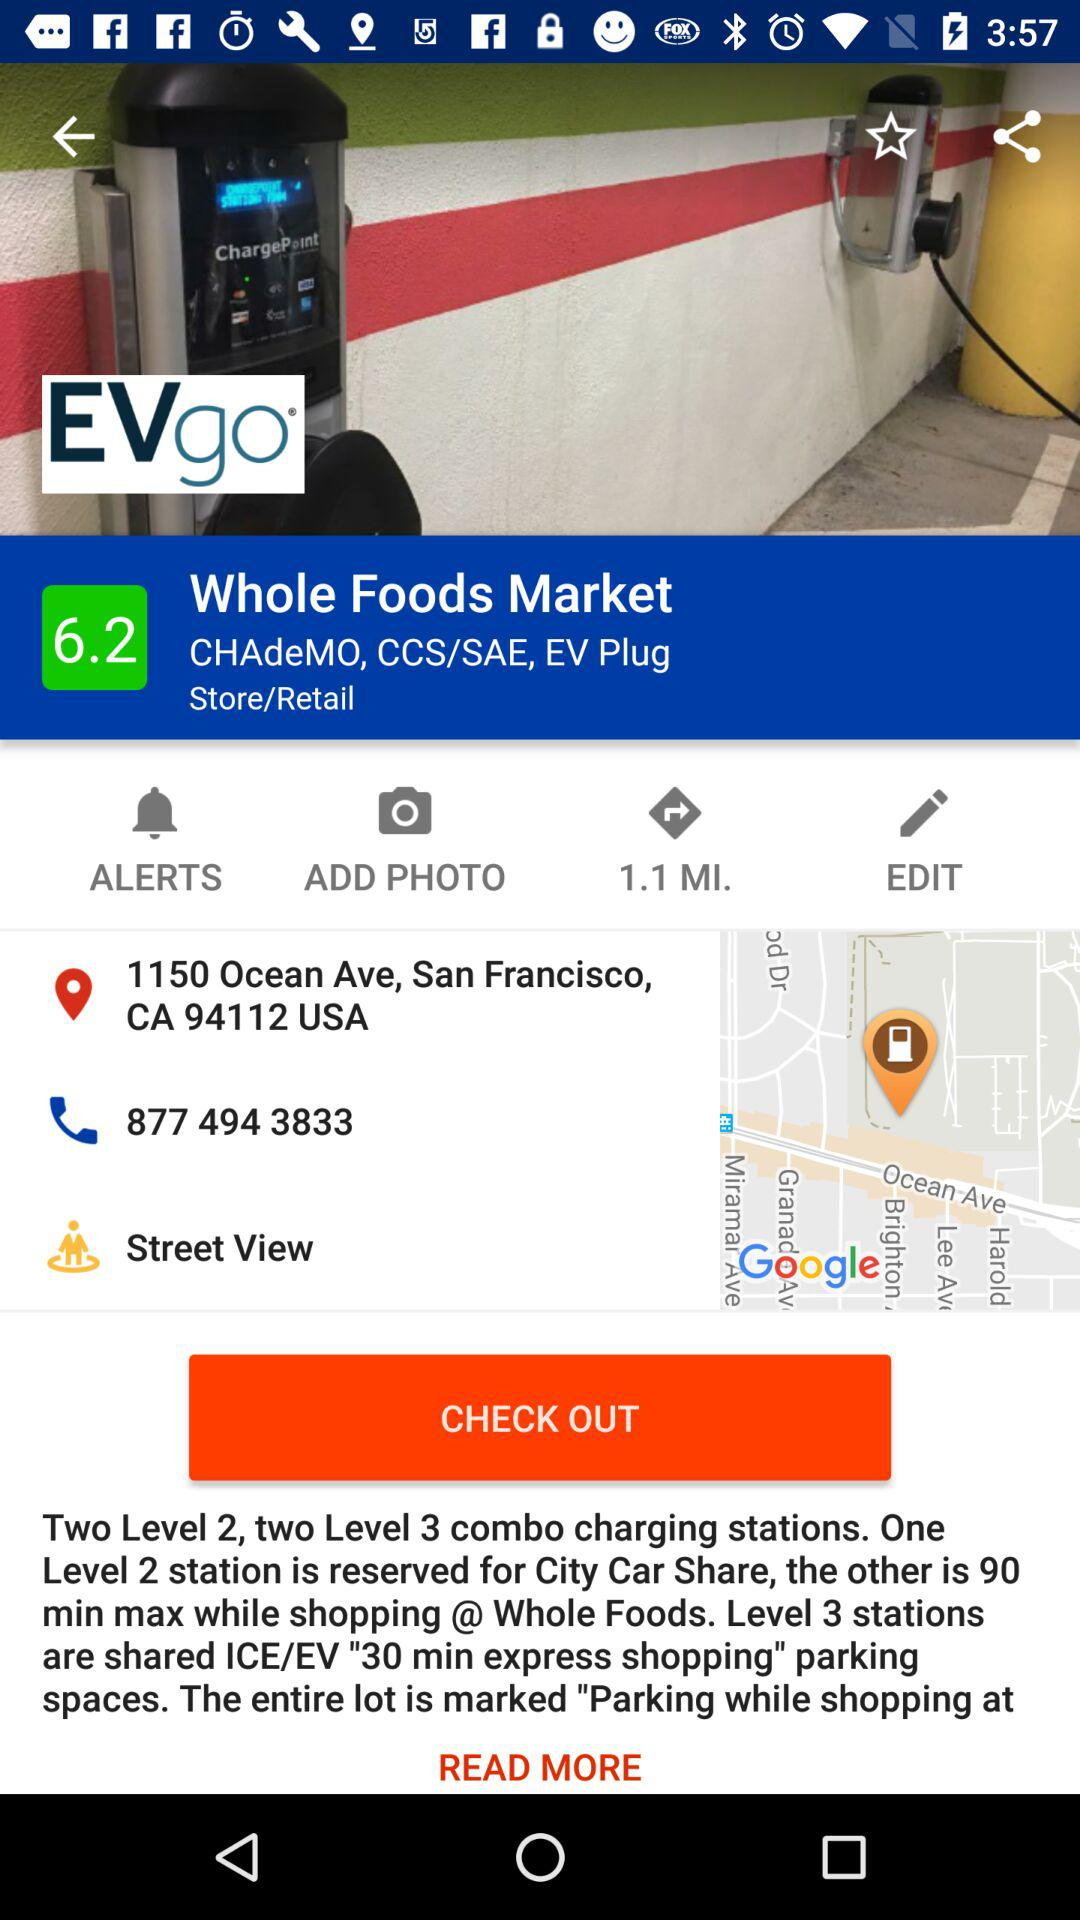How long is the maximum charging time for Level 2 stations?
Answer the question using a single word or phrase. 90 minutes 